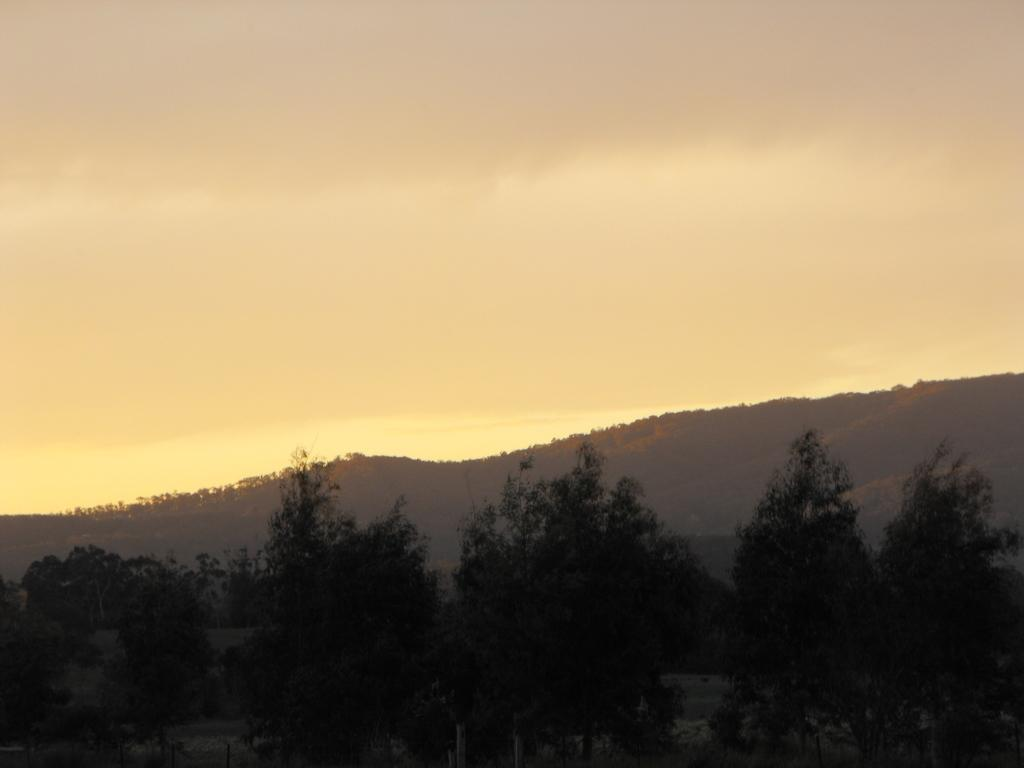What type of natural environment is depicted in the image? The image features many trees and hills, indicating a natural landscape. Can you describe the sky in the image? The sky is slightly cloudy in the image. Where is the goose located in the image? There is no goose present in the image. What type of farm animals can be seen grazing in the image? There are no farm animals present in the image. 